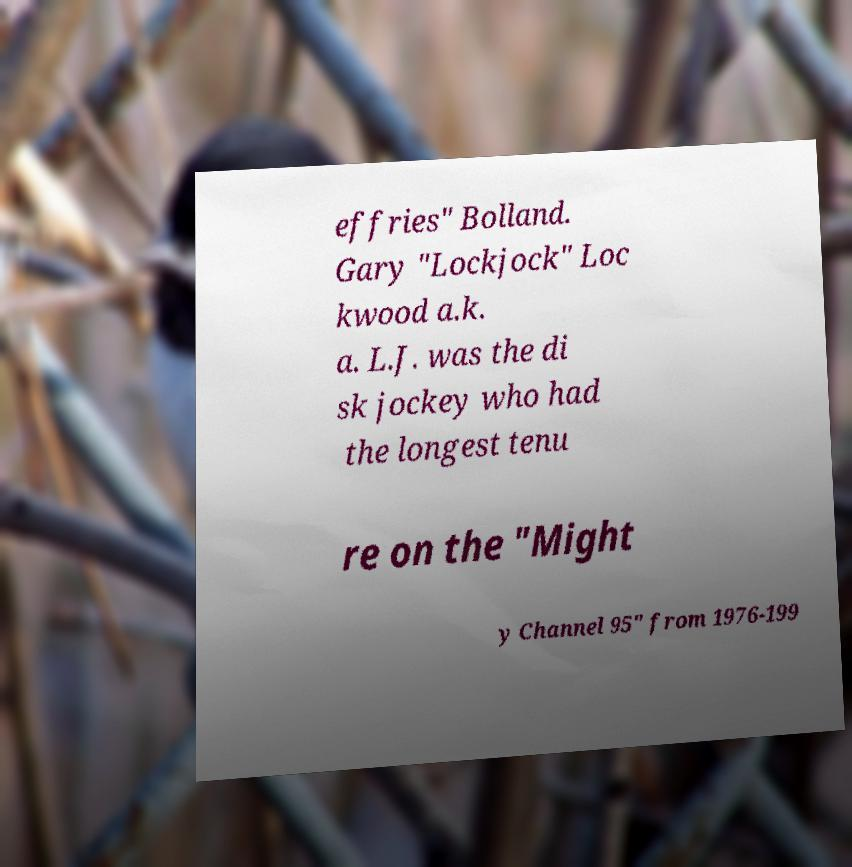There's text embedded in this image that I need extracted. Can you transcribe it verbatim? effries" Bolland. Gary "Lockjock" Loc kwood a.k. a. L.J. was the di sk jockey who had the longest tenu re on the "Might y Channel 95" from 1976-199 